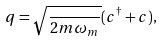Convert formula to latex. <formula><loc_0><loc_0><loc_500><loc_500>q = \sqrt { \frac { } { 2 m \omega _ { m } } } ( c ^ { \dagger } + c ) ,</formula> 